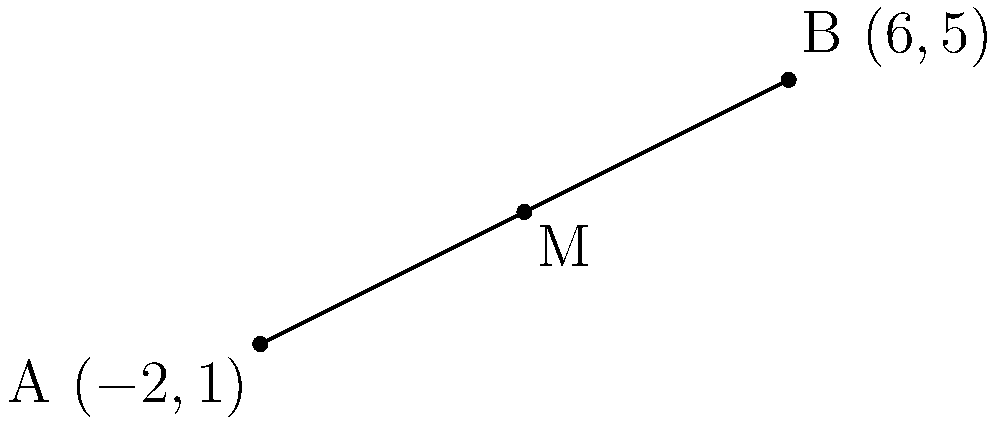Given the line segment AB with endpoints A(-2,1) and B(6,5), find the coordinates of the midpoint M. To find the coordinates of the midpoint M of line segment AB, we can use the midpoint formula:

$$ M = (\frac{x_1 + x_2}{2}, \frac{y_1 + y_2}{2}) $$

Where $(x_1, y_1)$ are the coordinates of point A and $(x_2, y_2)$ are the coordinates of point B.

Step 1: Identify the coordinates
A: $(-2, 1)$
B: $(6, 5)$

Step 2: Apply the midpoint formula for the x-coordinate
$x_M = \frac{x_1 + x_2}{2} = \frac{-2 + 6}{2} = \frac{4}{2} = 2$

Step 3: Apply the midpoint formula for the y-coordinate
$y_M = \frac{y_1 + y_2}{2} = \frac{1 + 5}{2} = \frac{6}{2} = 3$

Therefore, the coordinates of the midpoint M are (2, 3).
Answer: $(2, 3)$ 